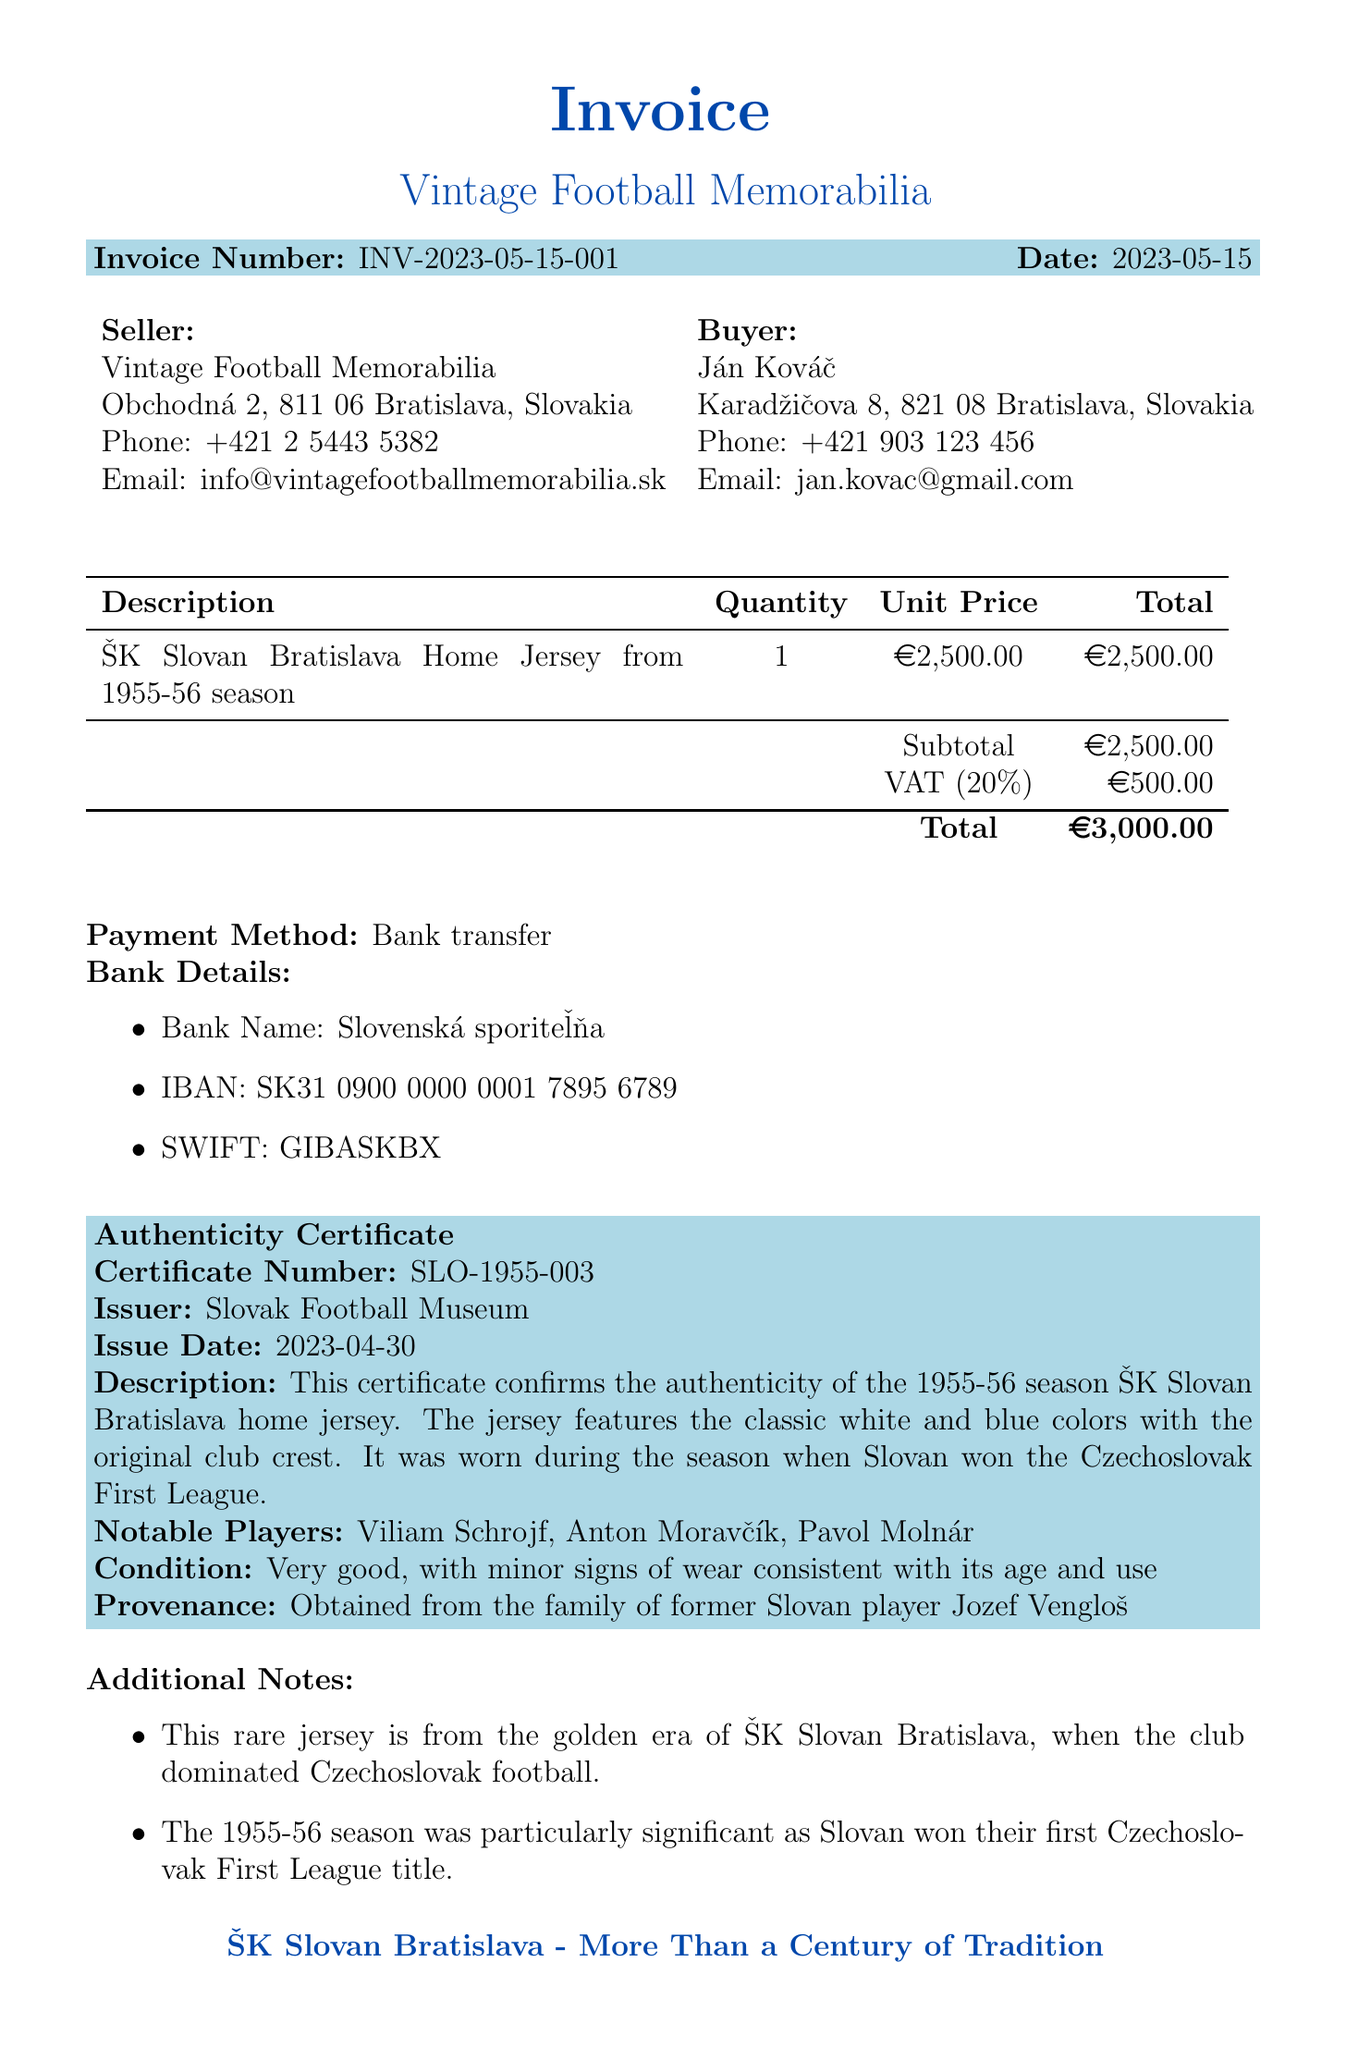What is the invoice number? The invoice number is a unique identifier for the transaction listed in the document.
Answer: INV-2023-05-15-001 Who is the seller? The seller's name and address are specified at the beginning of the document.
Answer: Vintage Football Memorabilia What is the total amount due? The total amount is the final figure after adding the subtotal and VAT.
Answer: 3000 EUR When was the jersey issued? The issue date of the invoice indicates when the transaction took place.
Answer: 2023-05-15 What is the authenticity certificate number? The document provides a unique certificate number for the authenticity of the jersey.
Answer: SLO-1955-003 Who issued the authenticity certificate? The issuer of the authenticity certificate is mentioned clearly in the document.
Answer: Slovak Football Museum How many notable players are listed? The document specifies a count of notable players associated with the jersey's authenticity.
Answer: 3 What payment method is used? The payment method indicates how the buyer is expected to pay for the jersey.
Answer: Bank transfer What was the condition of the jersey? The condition statement provides insights on the wear and tear of the vintage jersey.
Answer: Very good, with minor signs of wear consistent with its age and use 